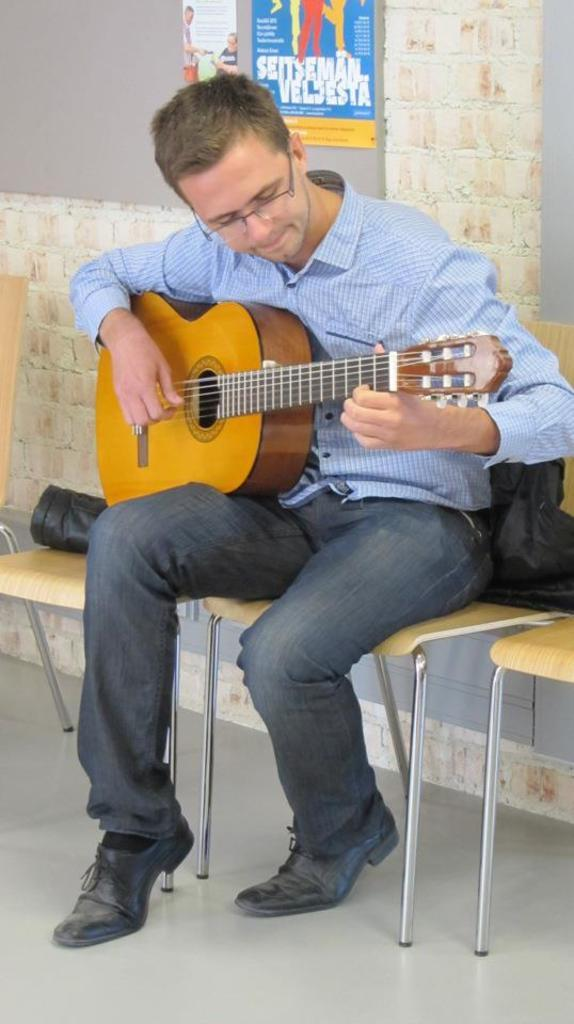What is the man in the image doing? The man is sitting on a chair in the image. What object is on the chair with the man? There is a black bag on the chair. What can be seen on the wall in the image? There is a poster on the wall. How many giraffes can be seen in the image? There are no giraffes present in the image. What type of trucks are visible in the image? There are no trucks visible in the image. 